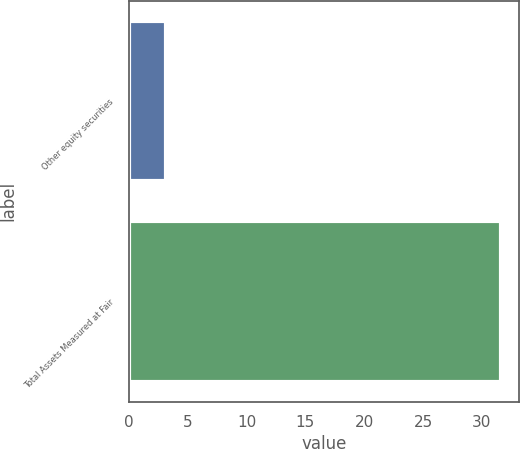Convert chart to OTSL. <chart><loc_0><loc_0><loc_500><loc_500><bar_chart><fcel>Other equity securities<fcel>Total Assets Measured at Fair<nl><fcel>3.2<fcel>31.6<nl></chart> 